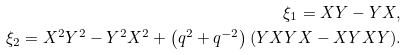Convert formula to latex. <formula><loc_0><loc_0><loc_500><loc_500>\xi _ { 1 } = X Y - Y X , \\ \xi _ { 2 } = X ^ { 2 } Y ^ { 2 } - Y ^ { 2 } X ^ { 2 } + \left ( q ^ { 2 } + q ^ { - 2 } \right ) ( Y X Y X - X Y X Y ) .</formula> 